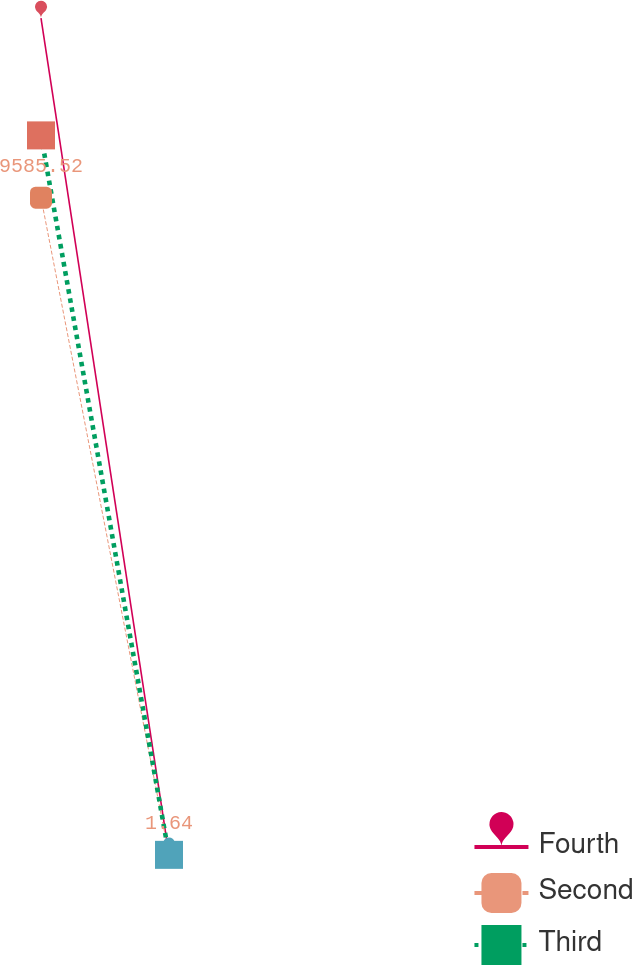<chart> <loc_0><loc_0><loc_500><loc_500><line_chart><ecel><fcel>Fourth<fcel>Second<fcel>Third<nl><fcel>154.09<fcel>12205<fcel>9585.52<fcel>10494.3<nl><fcel>1025.09<fcel>1.51<fcel>1.64<fcel>2.22<nl><fcel>8864.04<fcel>1221.86<fcel>960.03<fcel>1051.43<nl></chart> 